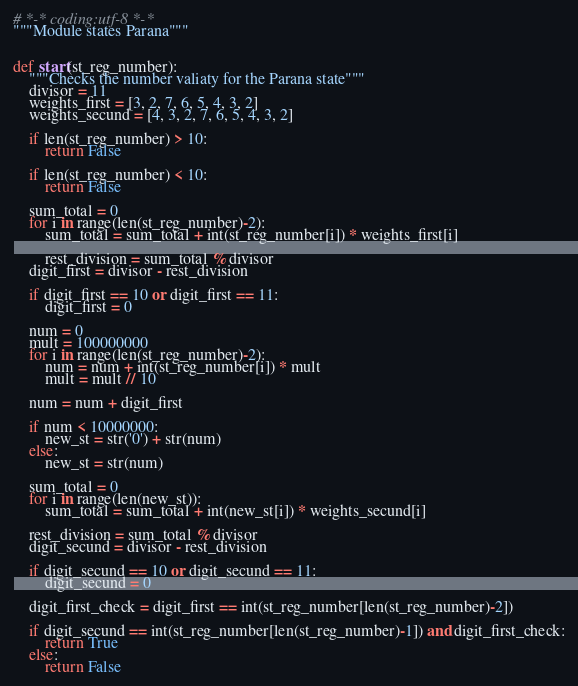<code> <loc_0><loc_0><loc_500><loc_500><_Python_># *-* coding:utf-8 *-*
"""Module states Parana"""


def start(st_reg_number):
    """Checks the number valiaty for the Parana state"""
    divisor = 11
    weights_first = [3, 2, 7, 6, 5, 4, 3, 2]
    weights_secund = [4, 3, 2, 7, 6, 5, 4, 3, 2]

    if len(st_reg_number) > 10:
        return False

    if len(st_reg_number) < 10:
        return False

    sum_total = 0
    for i in range(len(st_reg_number)-2):
        sum_total = sum_total + int(st_reg_number[i]) * weights_first[i]

        rest_division = sum_total % divisor
    digit_first = divisor - rest_division

    if digit_first == 10 or digit_first == 11:
        digit_first = 0

    num = 0
    mult = 100000000
    for i in range(len(st_reg_number)-2):
        num = num + int(st_reg_number[i]) * mult
        mult = mult // 10

    num = num + digit_first

    if num < 10000000:
        new_st = str('0') + str(num)
    else:
        new_st = str(num)

    sum_total = 0
    for i in range(len(new_st)):
        sum_total = sum_total + int(new_st[i]) * weights_secund[i]

    rest_division = sum_total % divisor
    digit_secund = divisor - rest_division

    if digit_secund == 10 or digit_secund == 11:
        digit_secund = 0

    digit_first_check = digit_first == int(st_reg_number[len(st_reg_number)-2])

    if digit_secund == int(st_reg_number[len(st_reg_number)-1]) and digit_first_check:
        return True
    else:
        return False
</code> 